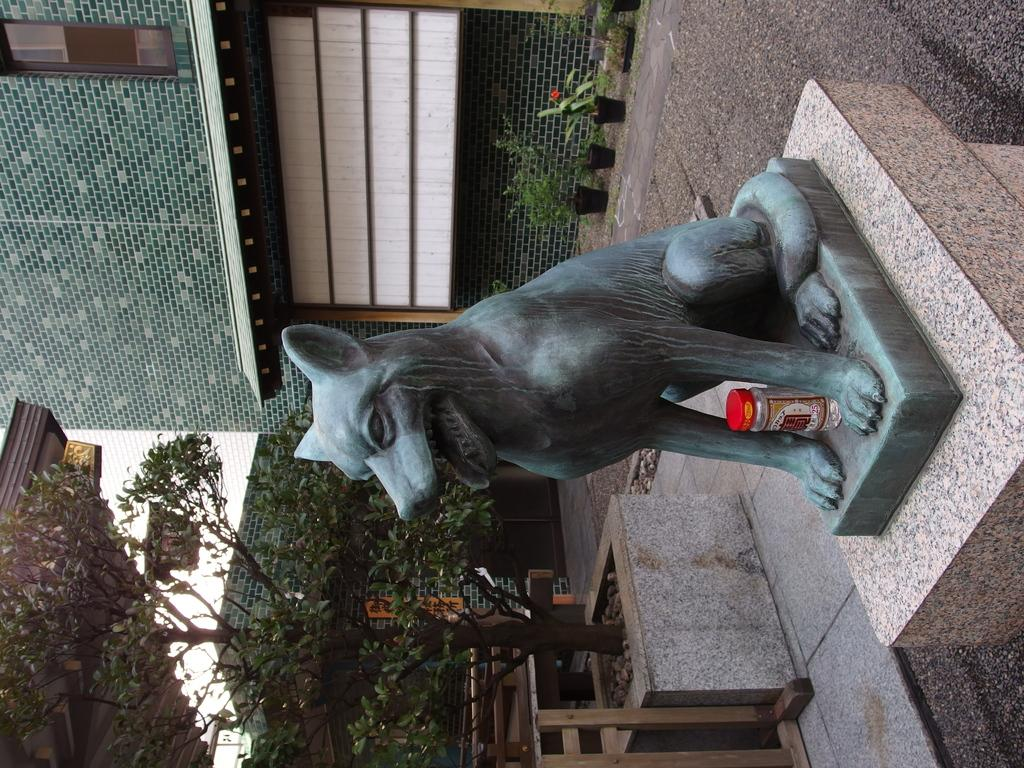What is the main subject of the image? There is a statue of an animal in the image. Where is the statue located? The statue is on a rock. What can be seen in the background of the image? There are trees and a building behind the statue. What type of drain is visible near the statue in the image? There is no drain visible near the statue in the image. Can you tell me the name of the creator of the animal statue in the image? The name of the creator of the animal statue is not mentioned in the image. 